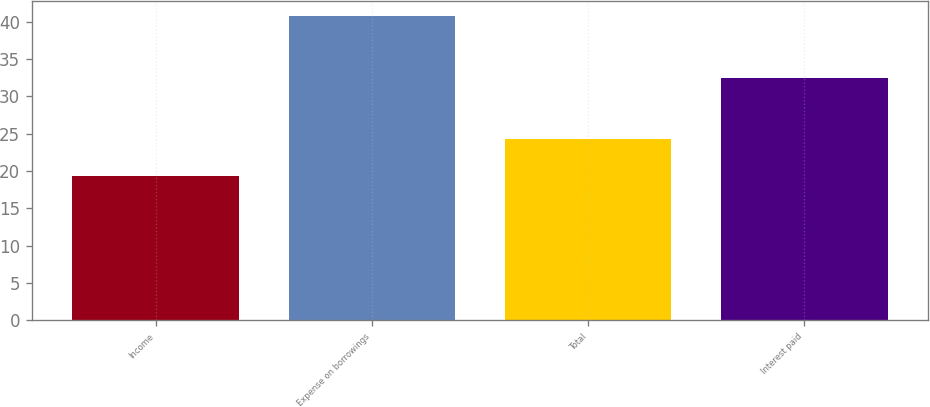Convert chart to OTSL. <chart><loc_0><loc_0><loc_500><loc_500><bar_chart><fcel>Income<fcel>Expense on borrowings<fcel>Total<fcel>Interest paid<nl><fcel>19.3<fcel>40.7<fcel>24.3<fcel>32.5<nl></chart> 